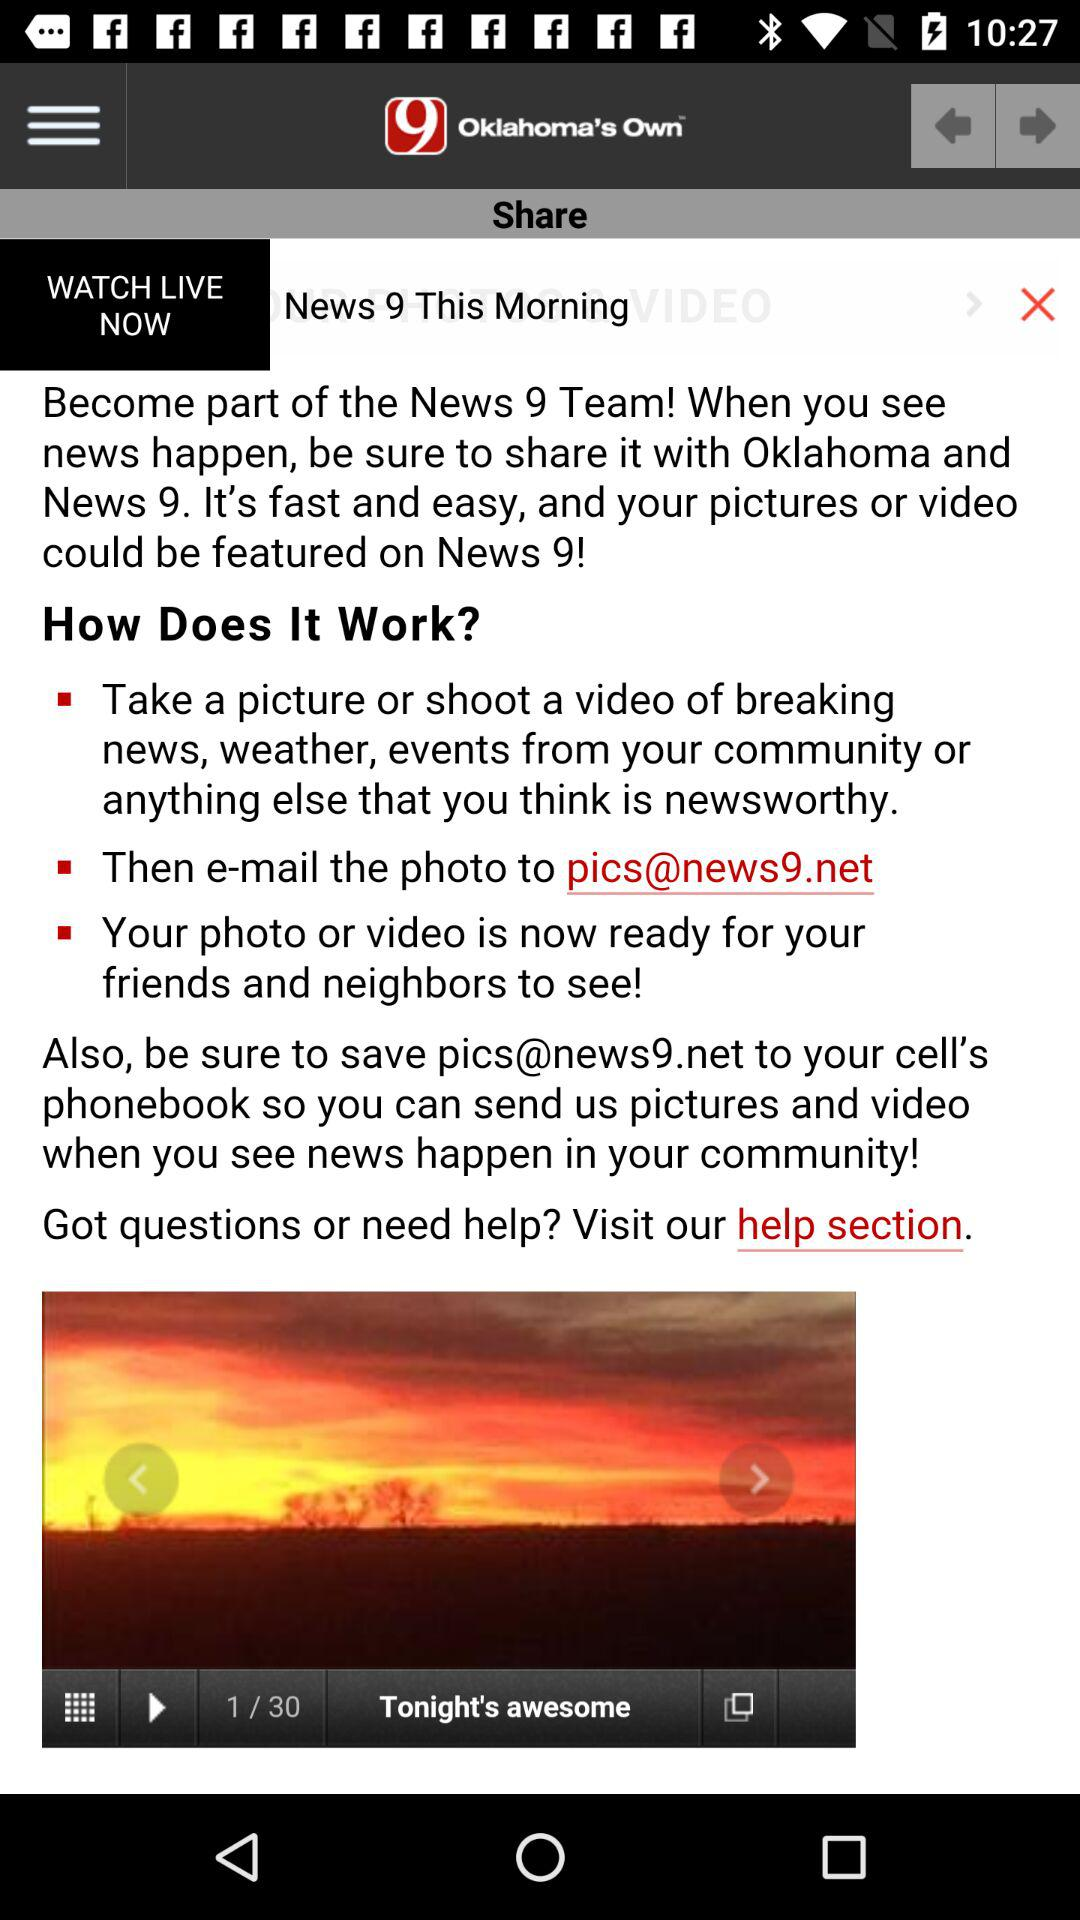What is the email address? The email address is pics@news9.net. 